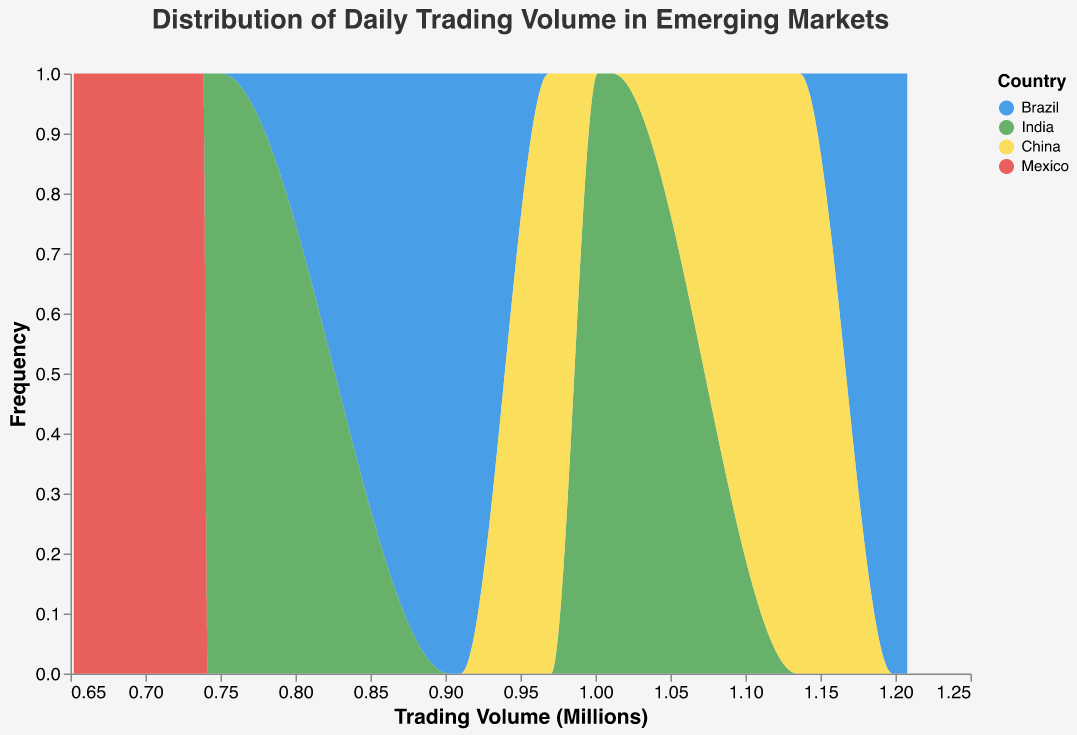What's the title of the figure? The title is usually at the top of the figure, indicating the main focus of the visualization.
Answer: Distribution of Daily Trading Volume in Emerging Markets What does the x-axis represent? The x-axis typically shows the variable being measured or recorded. In this case, it represents the trading volume in millions.
Answer: Trading Volume (Millions) Which country has the most frequent trading volume? By comparing the height of the area plots, we see which country frequently occurs across the x-axis range.
Answer: Brazil Which country shows the lowest frequency in trading volumes? By comparing the heights of the area plots, we determine which country appears less frequently.
Answer: Mexico What is the color used for China's trading volumes? The legend in the figure assigns a color to each country.
Answer: Yellow For which trading volume value does India show higher frequency than China? Identify the volume range on the x-axis where India's plot peaks higher than China's.
Answer: Around 1 million Is Mexico's trading volume distribution generally higher or lower compared to Brazil's? Comparing the overall height of Mexico's area plot to Brazil's shows how their frequencies stack up.
Answer: Lower What is the mean trading volume for stocks in China? To find the mean volume, average the volumes for China by summing and dividing by the number of data points for China (1134500+970300+1135700+968900+1135900+969100)/6.
Answer: Around 1.05 million Which country's trading volume distribution appears most volatile? Volatility is suggested by the spread and fluctuations in the frequency distribution. Determine this by the width and variations in the area's height.
Answer: Brazil 